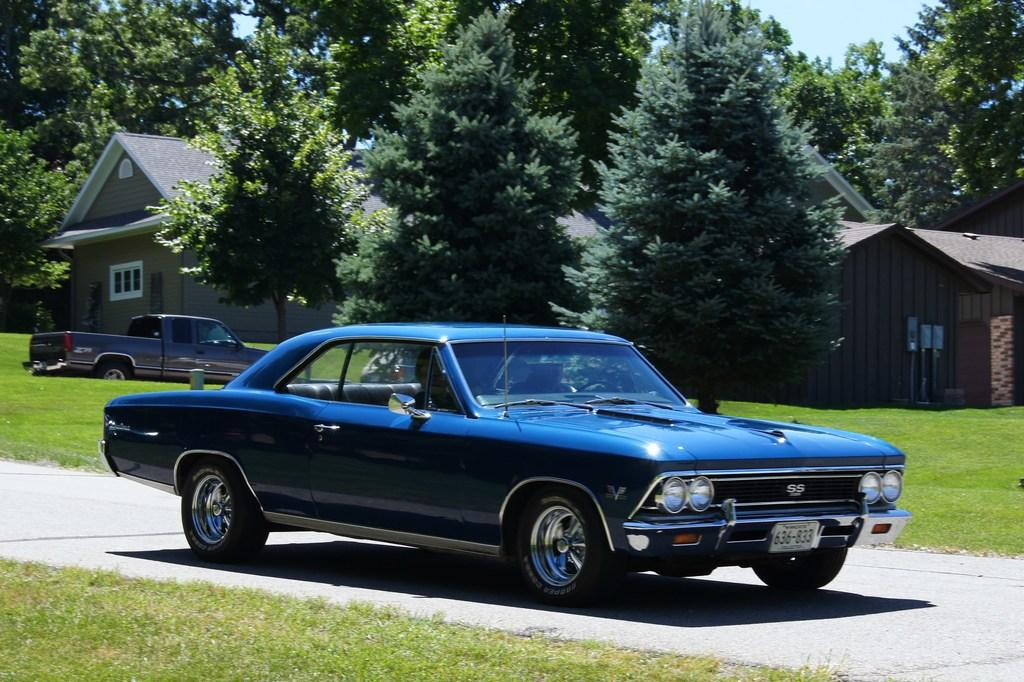What can be seen on the road in the image? There are vehicles on the road in the image. What type of structures are visible in the image? There are houses visible in the image. What type of vegetation is present in the image? There are trees in the image. What type of ground cover is visible in the image? There is grass visible in the image. What type of growth can be seen in the basket in the image? There is no basket present in the image, so it is not possible to determine what type of growth might be in it. 